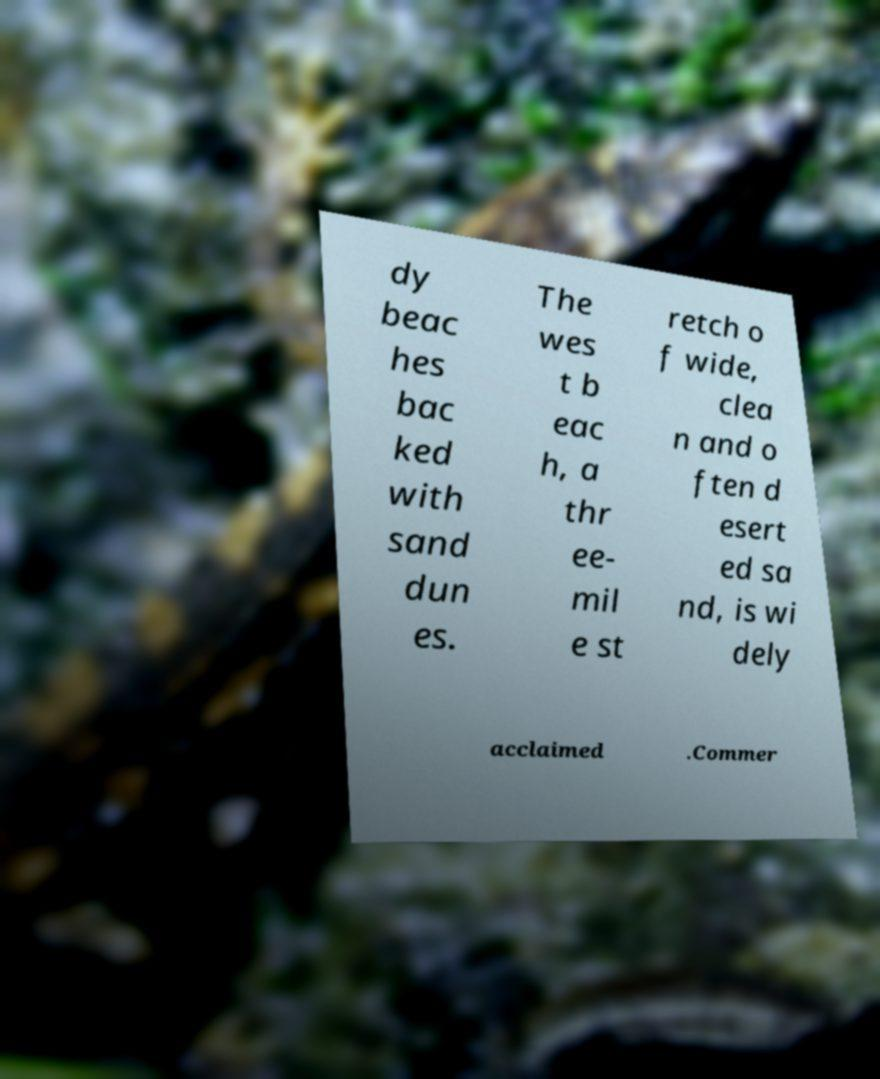Could you extract and type out the text from this image? dy beac hes bac ked with sand dun es. The wes t b eac h, a thr ee- mil e st retch o f wide, clea n and o ften d esert ed sa nd, is wi dely acclaimed .Commer 